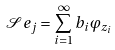<formula> <loc_0><loc_0><loc_500><loc_500>\mathcal { S } e _ { j } = \sum _ { i = 1 } ^ { \infty } b _ { i } \varphi _ { z _ { i } }</formula> 